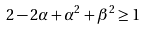<formula> <loc_0><loc_0><loc_500><loc_500>2 - 2 \alpha + \alpha ^ { 2 } + \beta ^ { 2 } \geq 1</formula> 